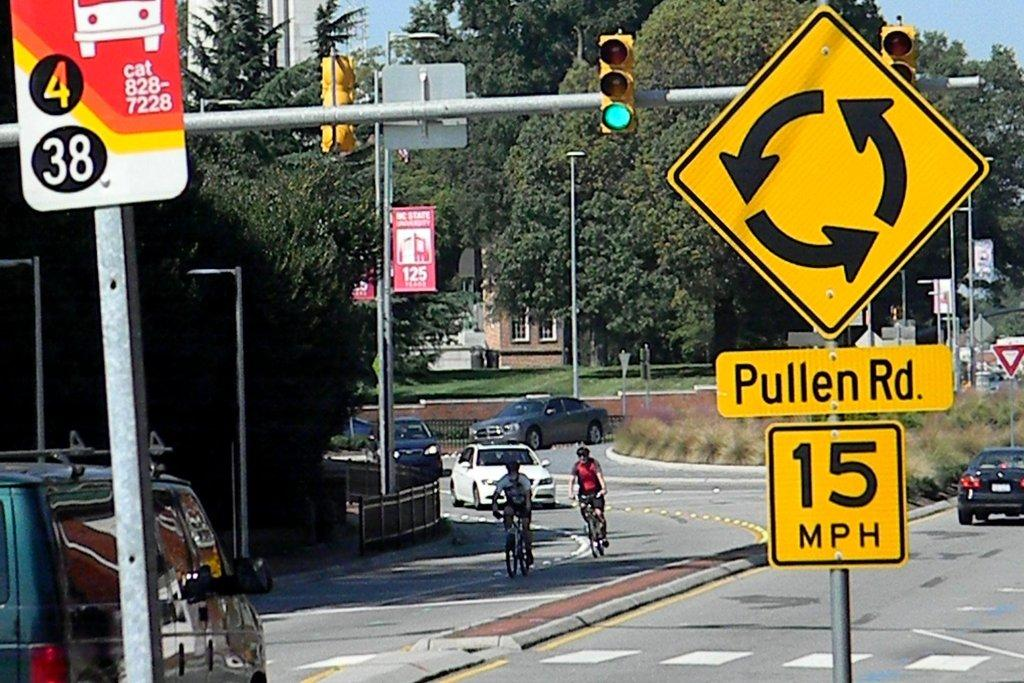<image>
Write a terse but informative summary of the picture. A busy roundabout with a 15 mph speed limit at Pullen Rd. 